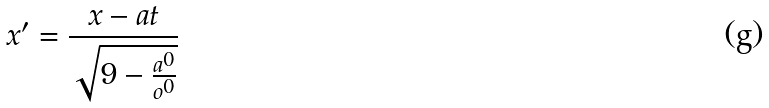<formula> <loc_0><loc_0><loc_500><loc_500>x ^ { \prime } = \frac { x - a t } { \sqrt { 9 - \frac { a ^ { 0 } } { o ^ { 0 } } } }</formula> 